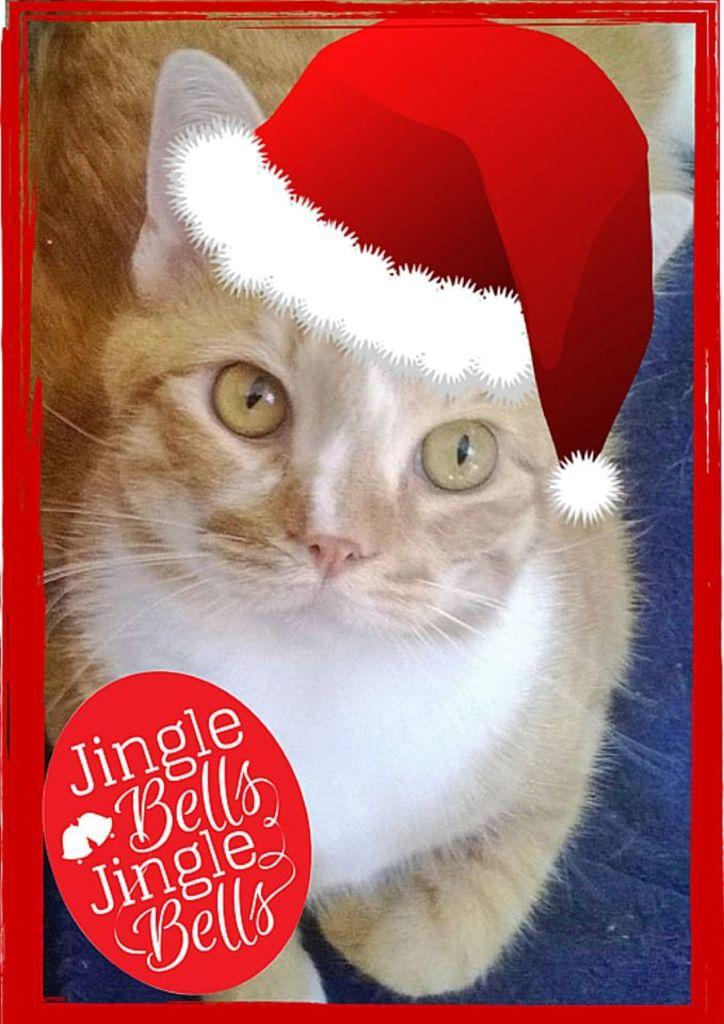What type of animal is in the image? There is a cat in the image. What color is the surface the cat is on? The cat is on a red surface. What is the color of the frame in the image? There is a red color frame in the image. What is the nature of the text in the image? The text in the image is edited. What type of cream can be seen being applied to the cat in the image? There is no cream being applied to the cat in the image. 